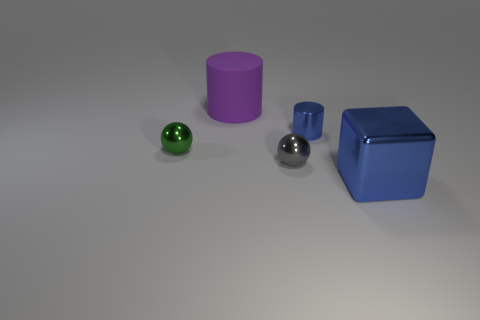Subtract all gray balls. How many balls are left? 1 Add 4 small cyan objects. How many objects exist? 9 Subtract all cylinders. How many objects are left? 3 Subtract all brown cubes. How many blue cylinders are left? 1 Subtract all tiny cylinders. Subtract all purple objects. How many objects are left? 3 Add 5 green shiny spheres. How many green shiny spheres are left? 6 Add 4 shiny objects. How many shiny objects exist? 8 Subtract 0 red balls. How many objects are left? 5 Subtract 1 cylinders. How many cylinders are left? 1 Subtract all gray balls. Subtract all blue cylinders. How many balls are left? 1 